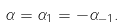Convert formula to latex. <formula><loc_0><loc_0><loc_500><loc_500>\alpha = \alpha _ { 1 } = - \alpha _ { - 1 } .</formula> 